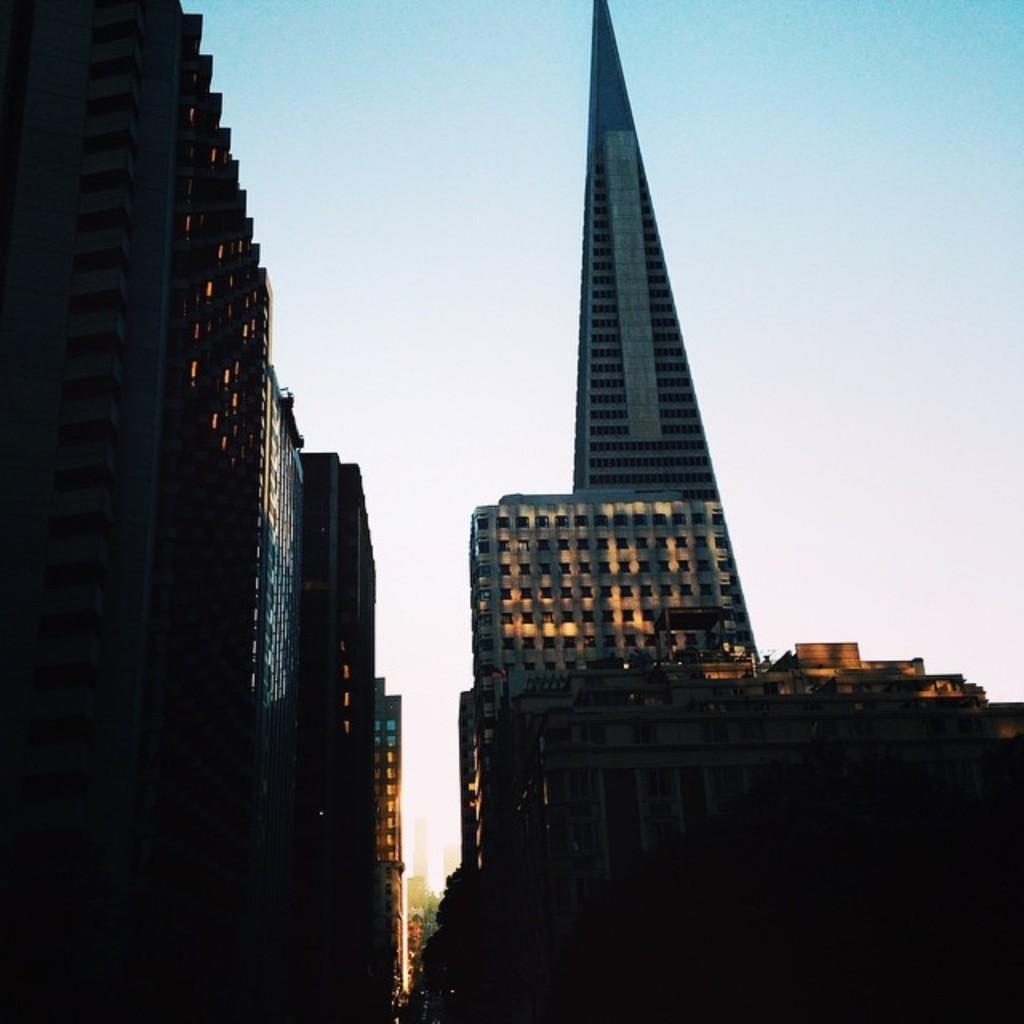In one or two sentences, can you explain what this image depicts? There are few buildings in the left corner and there is a tower building in the right corner and there are few buildings beside it. 